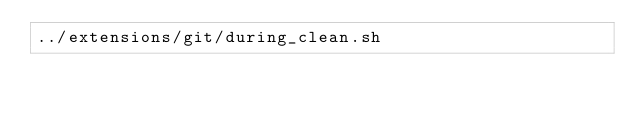<code> <loc_0><loc_0><loc_500><loc_500><_Bash_>../extensions/git/during_clean.sh</code> 